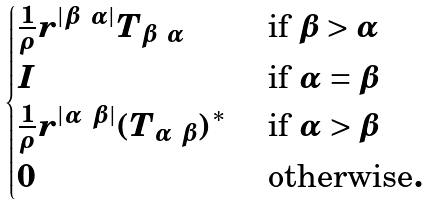<formula> <loc_0><loc_0><loc_500><loc_500>\begin{cases} \frac { 1 } { \rho } r ^ { | \beta \ \alpha | } T _ { \beta \ \alpha } & \text { if } \beta > \alpha \\ I & \text { if } \alpha = \beta \\ \frac { 1 } { \rho } r ^ { | \alpha \ \beta | } ( T _ { \alpha \ \beta } ) ^ { * } & \text { if } \alpha > \beta \\ 0 \quad & \text { otherwise} . \end{cases}</formula> 